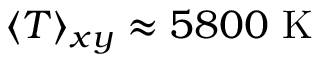Convert formula to latex. <formula><loc_0><loc_0><loc_500><loc_500>\langle T \rangle _ { x y } \approx 5 8 0 0 \ K</formula> 